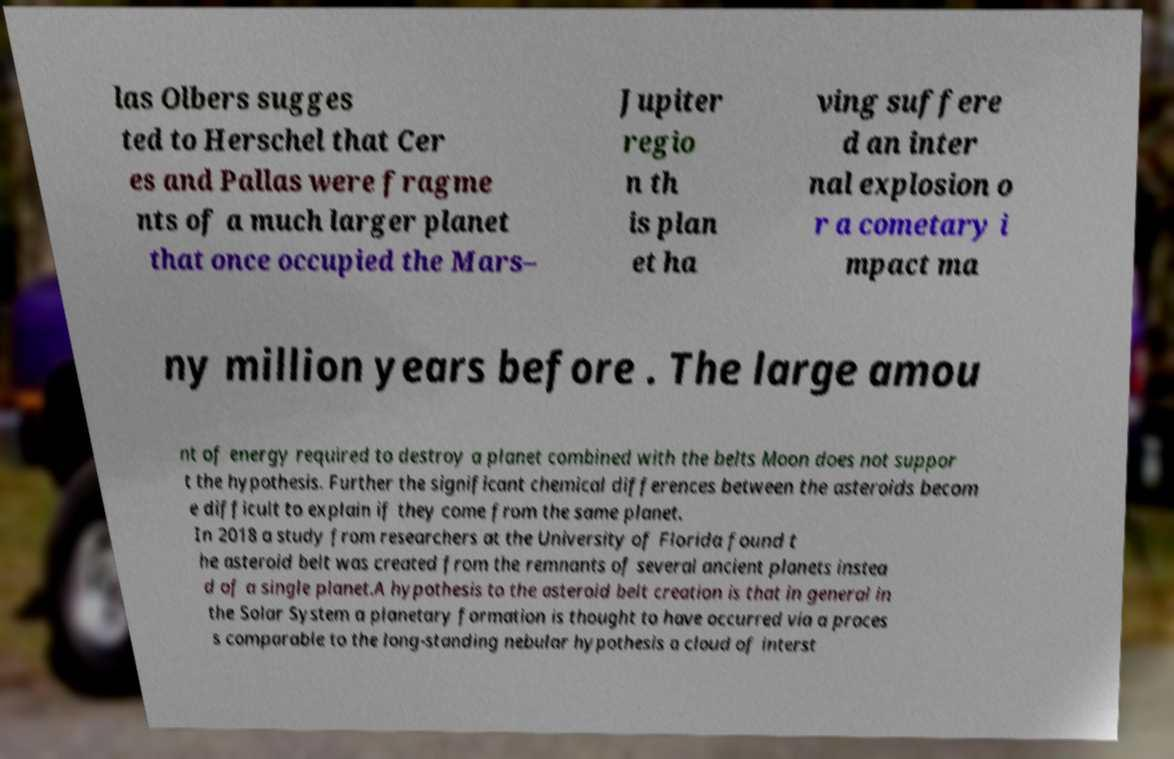I need the written content from this picture converted into text. Can you do that? las Olbers sugges ted to Herschel that Cer es and Pallas were fragme nts of a much larger planet that once occupied the Mars– Jupiter regio n th is plan et ha ving suffere d an inter nal explosion o r a cometary i mpact ma ny million years before . The large amou nt of energy required to destroy a planet combined with the belts Moon does not suppor t the hypothesis. Further the significant chemical differences between the asteroids becom e difficult to explain if they come from the same planet. In 2018 a study from researchers at the University of Florida found t he asteroid belt was created from the remnants of several ancient planets instea d of a single planet.A hypothesis to the asteroid belt creation is that in general in the Solar System a planetary formation is thought to have occurred via a proces s comparable to the long-standing nebular hypothesis a cloud of interst 